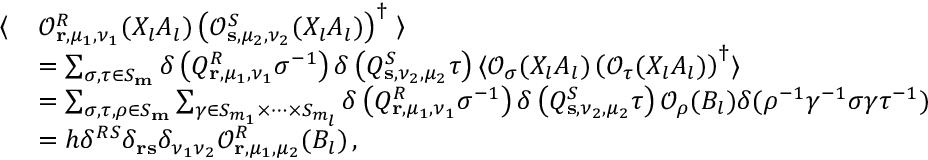<formula> <loc_0><loc_0><loc_500><loc_500>\begin{array} { r l } { \left \langle } & { \mathcal { O } _ { r , \mu _ { 1 } , \nu _ { 1 } } ^ { R } ( X _ { l } A _ { l } ) \left ( \mathcal { O } _ { s , \mu _ { 2 } , \nu _ { 2 } } ^ { S } ( X _ { l } A _ { l } ) \right ) ^ { \dagger } \right \rangle } \\ & { = \sum _ { \sigma , \tau \in S _ { m } } \delta \left ( Q _ { r , \mu _ { 1 } , \nu _ { 1 } } ^ { R } \sigma ^ { - 1 } \right ) \delta \left ( Q _ { s , \nu _ { 2 } , \mu _ { 2 } } ^ { S } \tau \right ) \langle \mathcal { O } _ { \sigma } ( X _ { l } A _ { l } ) \left ( \mathcal { O } _ { \tau } ( X _ { l } A _ { l } ) \right ) ^ { \dagger } \rangle } \\ & { = \sum _ { \sigma , \tau , \rho \in S _ { m } } \sum _ { \gamma \in S _ { m _ { 1 } } \times \dots \times S _ { m _ { l } } } \delta \left ( Q _ { r , \mu _ { 1 } , \nu _ { 1 } } ^ { R } \sigma ^ { - 1 } \right ) \delta \left ( Q _ { s , \nu _ { 2 } , \mu _ { 2 } } ^ { S } \tau \right ) \mathcal { O } _ { \rho } ( B _ { l } ) \delta ( \rho ^ { - 1 } \gamma ^ { - 1 } \sigma \gamma \tau ^ { - 1 } ) } \\ & { = h \delta ^ { R S } \delta _ { r s } \delta _ { \nu _ { 1 } \nu _ { 2 } } \mathcal { O } _ { r , \mu _ { 1 } , \mu _ { 2 } } ^ { R } ( B _ { l } ) \, , } \end{array}</formula> 